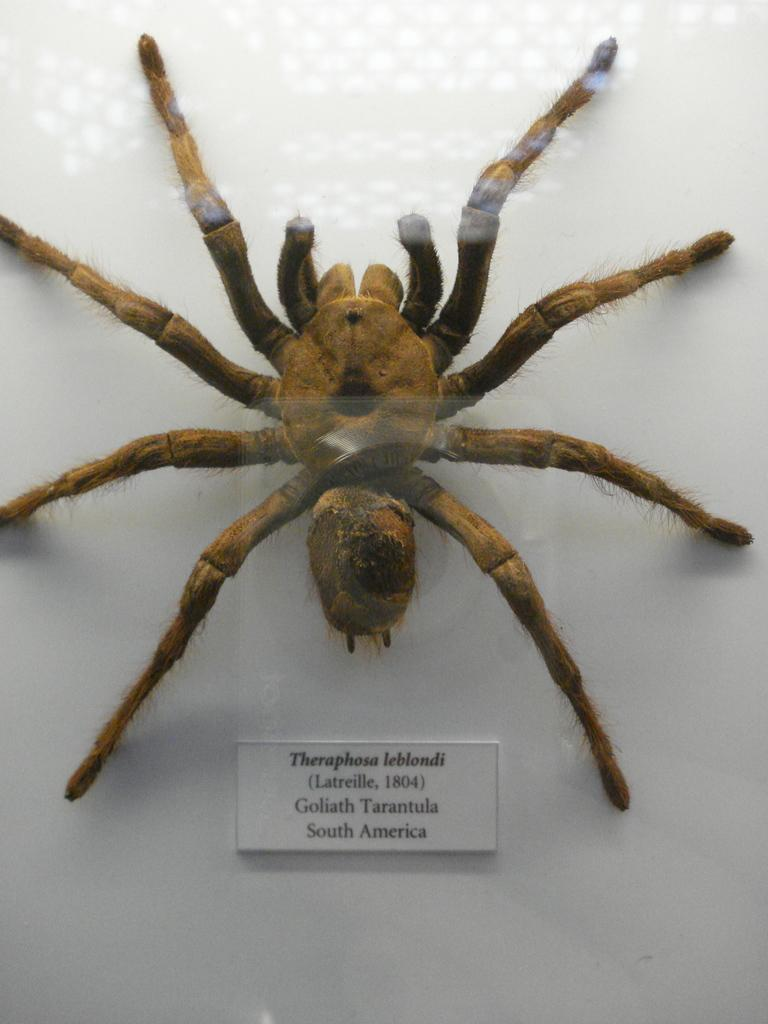What is the main subject of the image? The main subject of the image is a spider. What is the color of the surface where the spider is located? The spider is on a white surface. What other object can be seen in the image besides the spider? There is a sticker with text in the image. What type of shoe is the spider wearing in the image? There is no shoe present in the image, as the spider is not wearing any footwear. 